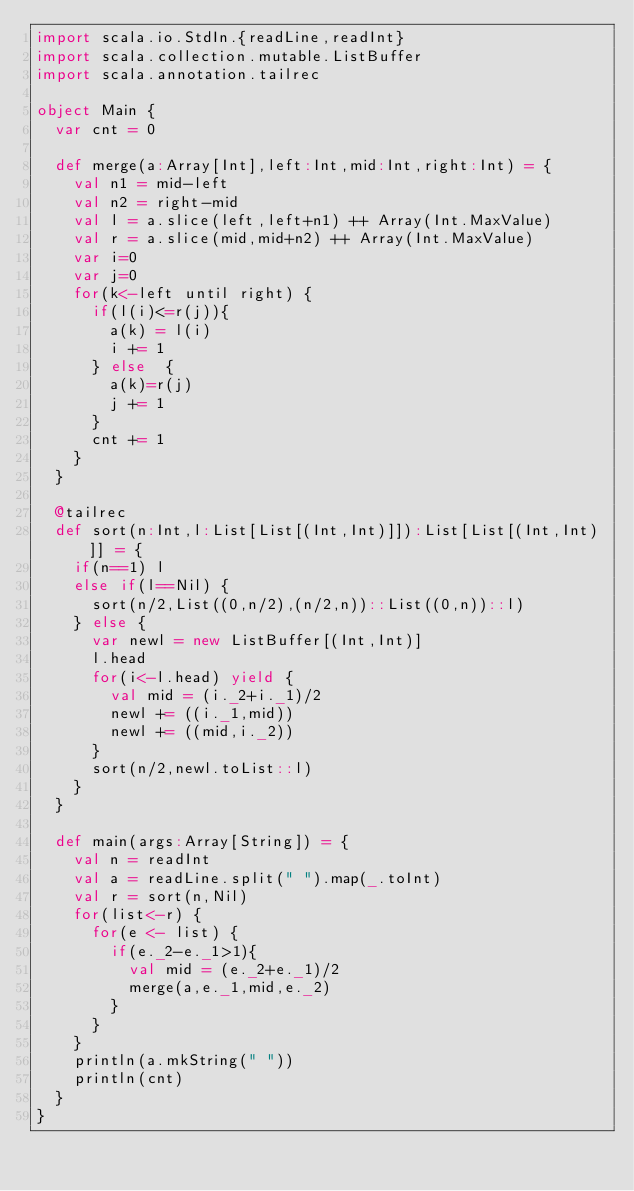Convert code to text. <code><loc_0><loc_0><loc_500><loc_500><_Scala_>import scala.io.StdIn.{readLine,readInt}
import scala.collection.mutable.ListBuffer
import scala.annotation.tailrec

object Main {
  var cnt = 0

  def merge(a:Array[Int],left:Int,mid:Int,right:Int) = {
    val n1 = mid-left
    val n2 = right-mid
    val l = a.slice(left,left+n1) ++ Array(Int.MaxValue)
    val r = a.slice(mid,mid+n2) ++ Array(Int.MaxValue)
    var i=0
    var j=0
    for(k<-left until right) {
      if(l(i)<=r(j)){
        a(k) = l(i)
        i += 1
      } else  {
        a(k)=r(j)
        j += 1
      }
      cnt += 1
    }
  }

  @tailrec
  def sort(n:Int,l:List[List[(Int,Int)]]):List[List[(Int,Int)]] = {
    if(n==1) l
    else if(l==Nil) {
      sort(n/2,List((0,n/2),(n/2,n))::List((0,n))::l)
    } else {
      var newl = new ListBuffer[(Int,Int)]
      l.head
      for(i<-l.head) yield {
        val mid = (i._2+i._1)/2
        newl += ((i._1,mid))
        newl += ((mid,i._2))
      }
      sort(n/2,newl.toList::l)
    }
  }

  def main(args:Array[String]) = {
    val n = readInt
    val a = readLine.split(" ").map(_.toInt)
    val r = sort(n,Nil)
    for(list<-r) {
      for(e <- list) {
        if(e._2-e._1>1){
          val mid = (e._2+e._1)/2
          merge(a,e._1,mid,e._2)
        }
      }
    }
    println(a.mkString(" "))
    println(cnt)
  }
}</code> 